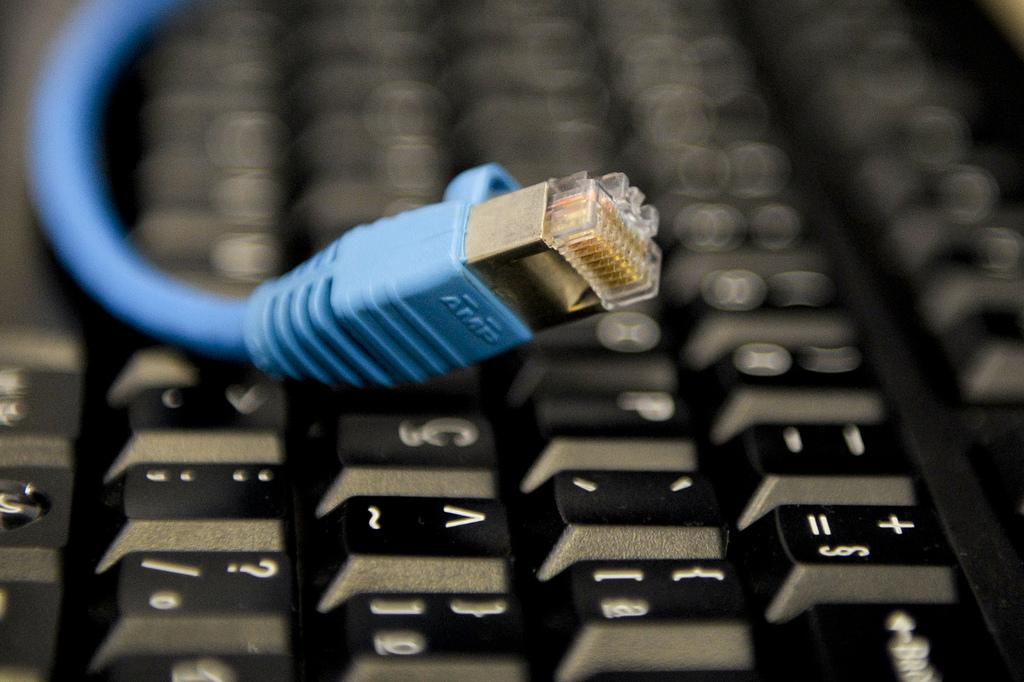<image>
Summarize the visual content of the image. a blue AMP brand electronic's cord on top of a black keyboard. 